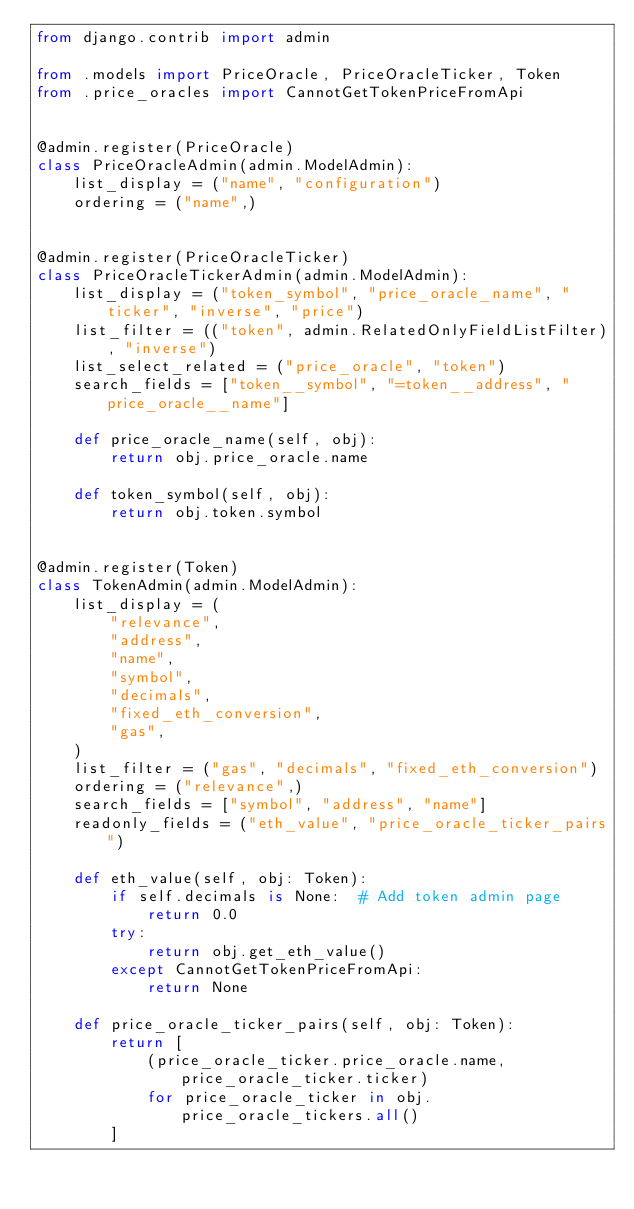<code> <loc_0><loc_0><loc_500><loc_500><_Python_>from django.contrib import admin

from .models import PriceOracle, PriceOracleTicker, Token
from .price_oracles import CannotGetTokenPriceFromApi


@admin.register(PriceOracle)
class PriceOracleAdmin(admin.ModelAdmin):
    list_display = ("name", "configuration")
    ordering = ("name",)


@admin.register(PriceOracleTicker)
class PriceOracleTickerAdmin(admin.ModelAdmin):
    list_display = ("token_symbol", "price_oracle_name", "ticker", "inverse", "price")
    list_filter = (("token", admin.RelatedOnlyFieldListFilter), "inverse")
    list_select_related = ("price_oracle", "token")
    search_fields = ["token__symbol", "=token__address", "price_oracle__name"]

    def price_oracle_name(self, obj):
        return obj.price_oracle.name

    def token_symbol(self, obj):
        return obj.token.symbol


@admin.register(Token)
class TokenAdmin(admin.ModelAdmin):
    list_display = (
        "relevance",
        "address",
        "name",
        "symbol",
        "decimals",
        "fixed_eth_conversion",
        "gas",
    )
    list_filter = ("gas", "decimals", "fixed_eth_conversion")
    ordering = ("relevance",)
    search_fields = ["symbol", "address", "name"]
    readonly_fields = ("eth_value", "price_oracle_ticker_pairs")

    def eth_value(self, obj: Token):
        if self.decimals is None:  # Add token admin page
            return 0.0
        try:
            return obj.get_eth_value()
        except CannotGetTokenPriceFromApi:
            return None

    def price_oracle_ticker_pairs(self, obj: Token):
        return [
            (price_oracle_ticker.price_oracle.name, price_oracle_ticker.ticker)
            for price_oracle_ticker in obj.price_oracle_tickers.all()
        ]
</code> 